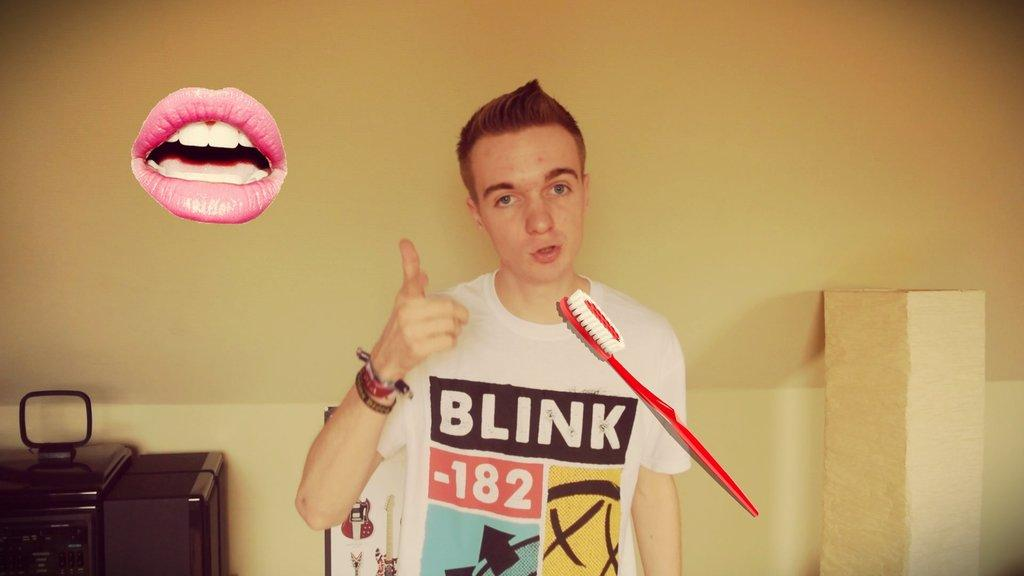<image>
Offer a succinct explanation of the picture presented. A boy wearing a Blink 182 shirt holds up his thumb. 